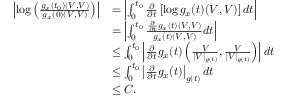Convert formula to latex. <formula><loc_0><loc_0><loc_500><loc_500>\begin{array} { r l } { \left | \log \left ( \frac { g _ { x } ( t _ { 0 } ) ( V , V ) } { g _ { x } ( 0 ) ( V , V ) } \right ) \right | } & { = \left | \int _ { 0 } ^ { t _ { 0 } } \frac { \partial } { \partial t } \left [ \log g _ { x } ( t ) ( V , V ) \right ] d t \right | } \\ & { = \left | \int _ { 0 } ^ { t _ { 0 } } \frac { \frac { \partial } { \partial t } g _ { x } ( t ) ( V , V ) } { g _ { x } ( t ) ( V , V ) } d t \right | } \\ & { \leq \int _ { 0 } ^ { t _ { 0 } } \left | \frac { \partial } { \partial t } g _ { x } ( t ) \left ( \frac { V } { | V | _ { g ( t ) } } , \frac { V } { | V | _ { g ( t ) } } \right ) \right | d t } \\ & { \leq \int _ { 0 } ^ { t _ { 0 } } \left | \frac { \partial } { \partial t } g _ { x } ( t ) \right | _ { g ( t ) } d t } \\ & { \leq C . } \end{array}</formula> 